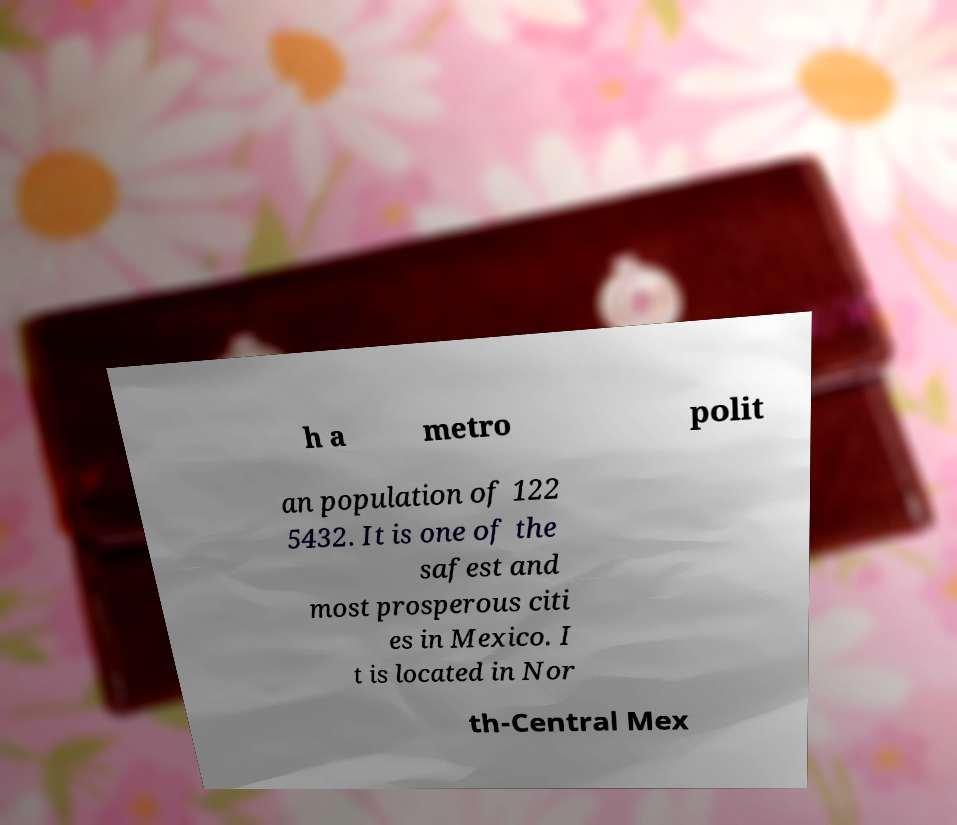There's text embedded in this image that I need extracted. Can you transcribe it verbatim? h a metro polit an population of 122 5432. It is one of the safest and most prosperous citi es in Mexico. I t is located in Nor th-Central Mex 